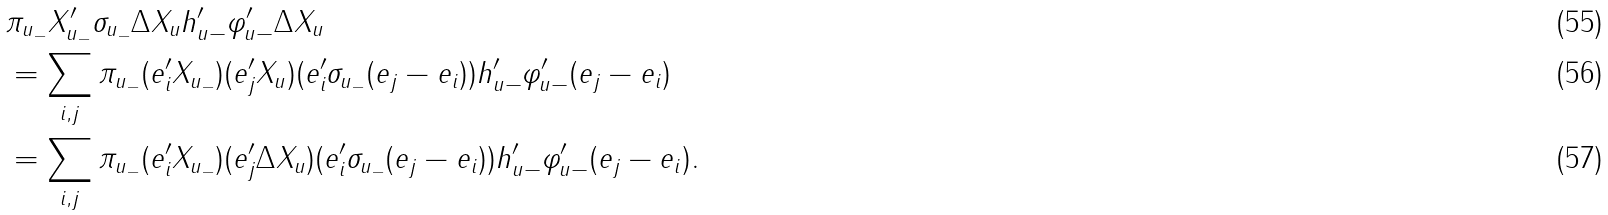Convert formula to latex. <formula><loc_0><loc_0><loc_500><loc_500>& \pi _ { u _ { - } } X ^ { \prime } _ { u _ { - } } \sigma _ { u _ { - } } \Delta X _ { u } h ^ { \prime } _ { u - } \varphi ^ { \prime } _ { u - } \Delta X _ { u } \\ & = \sum _ { i , j } \pi _ { u _ { - } } ( e ^ { \prime } _ { i } X _ { u _ { - } } ) ( e ^ { \prime } _ { j } X _ { u } ) ( e ^ { \prime } _ { i } \sigma _ { u _ { - } } ( e _ { j } - e _ { i } ) ) h ^ { \prime } _ { u - } \varphi ^ { \prime } _ { u - } ( e _ { j } - e _ { i } ) \\ & = \sum _ { i , j } \pi _ { u _ { - } } ( e ^ { \prime } _ { i } X _ { u _ { - } } ) ( e ^ { \prime } _ { j } \Delta X _ { u } ) ( e ^ { \prime } _ { i } \sigma _ { u _ { - } } ( e _ { j } - e _ { i } ) ) h ^ { \prime } _ { u - } \varphi ^ { \prime } _ { u - } ( e _ { j } - e _ { i } ) .</formula> 